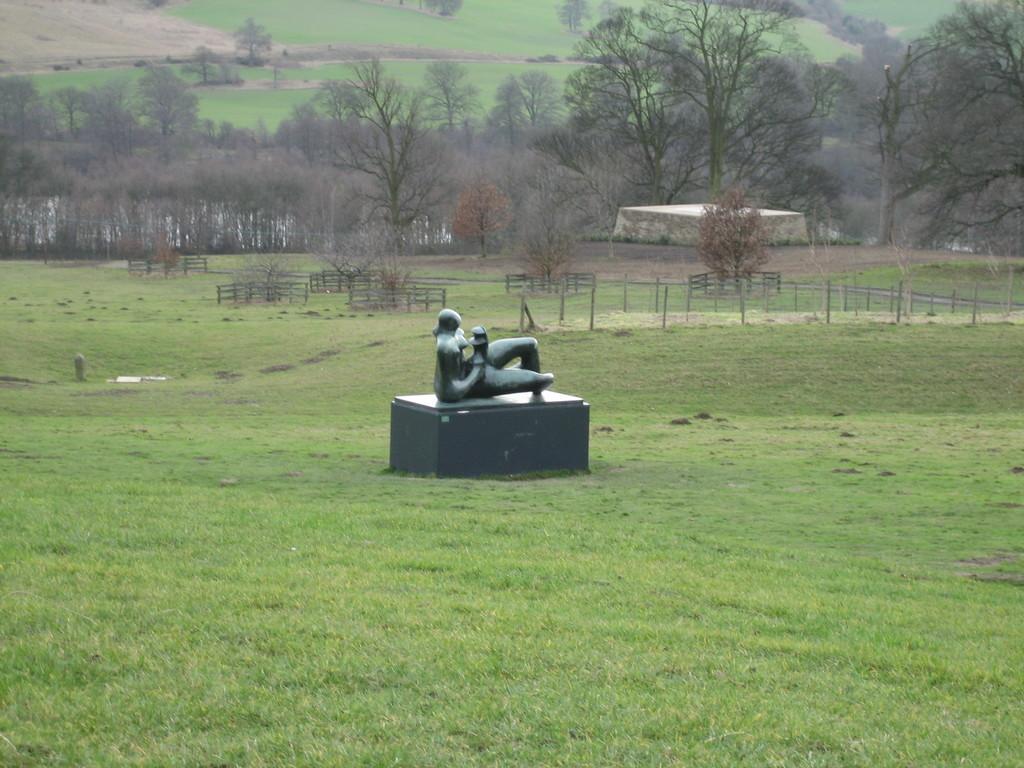Could you give a brief overview of what you see in this image? In this image on the ground there is a sculpture, trees, poles, there may be water behind the tree on the left side. 